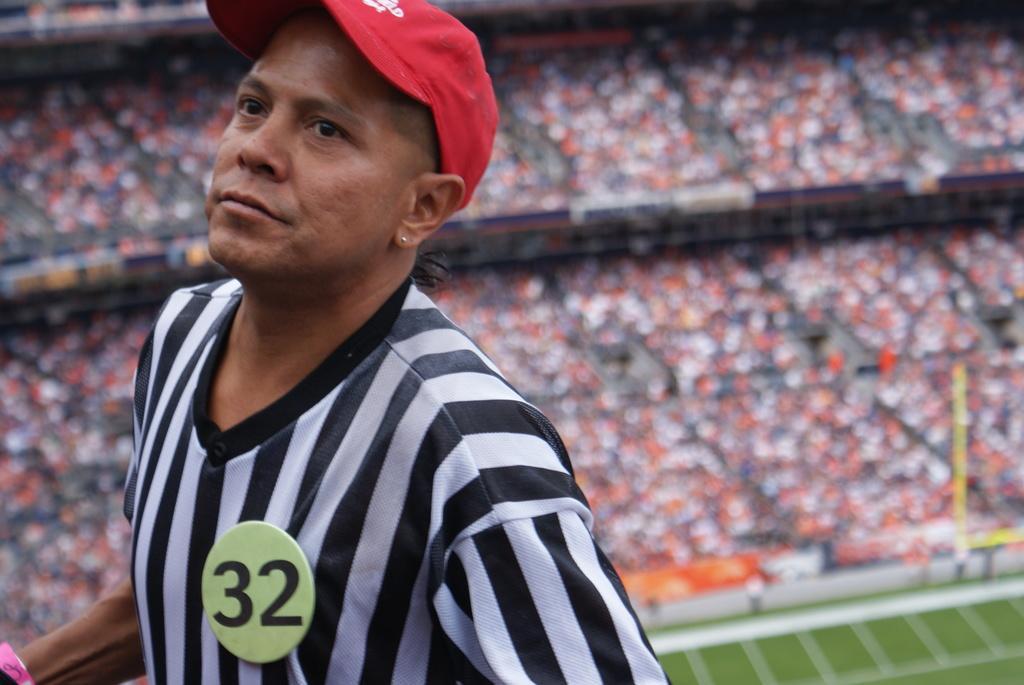Could you give a brief overview of what you see in this image? In this image I can see a person wearing white and black colored dress and red colored hat is standing. I can see a badge to his shirt. In the background I can see the ground, a yellow colored pole and number of persons in the stadium. 